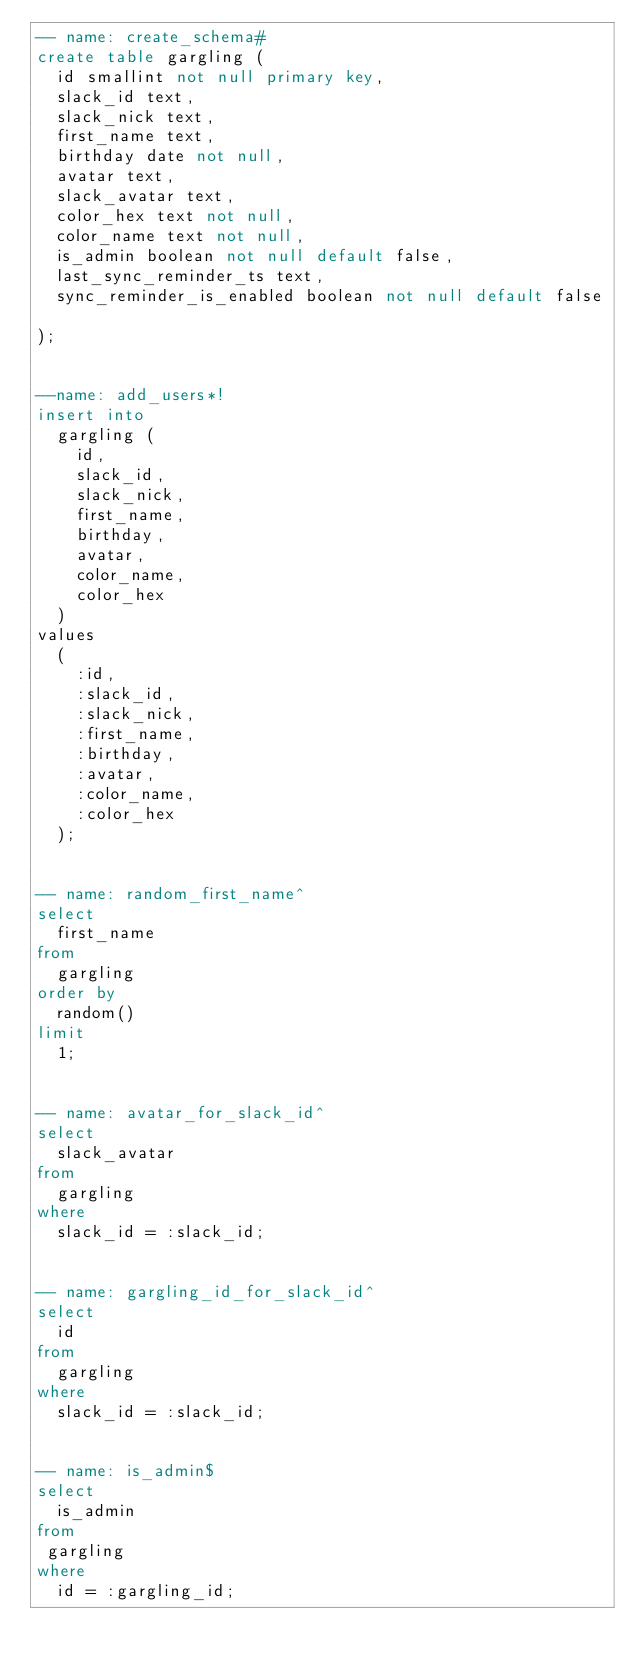Convert code to text. <code><loc_0><loc_0><loc_500><loc_500><_SQL_>-- name: create_schema#
create table gargling (
  id smallint not null primary key,
  slack_id text,
  slack_nick text,
  first_name text,
  birthday date not null,
  avatar text,
  slack_avatar text,
  color_hex text not null,
  color_name text not null,
  is_admin boolean not null default false,
  last_sync_reminder_ts text,
  sync_reminder_is_enabled boolean not null default false

);


--name: add_users*!
insert into
  gargling (
    id,
    slack_id,
    slack_nick,
    first_name,
    birthday,
    avatar,
    color_name,
    color_hex
  )
values
  (
    :id,
    :slack_id,
    :slack_nick,
    :first_name,
    :birthday,
    :avatar,
    :color_name,
    :color_hex
  );


-- name: random_first_name^
select
  first_name
from
  gargling
order by
  random()
limit
  1;


-- name: avatar_for_slack_id^
select
  slack_avatar
from
  gargling
where
  slack_id = :slack_id;


-- name: gargling_id_for_slack_id^
select
  id
from
  gargling
where
  slack_id = :slack_id;


-- name: is_admin$
select
  is_admin
from
 gargling
where
  id = :gargling_id;
</code> 